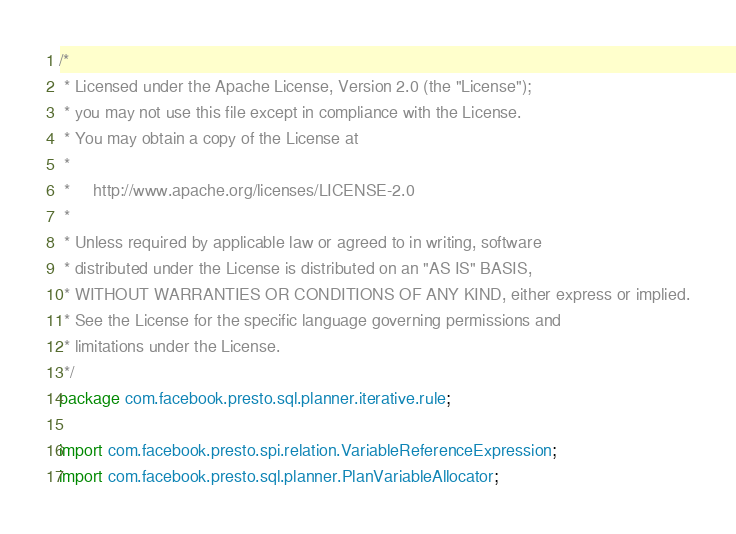Convert code to text. <code><loc_0><loc_0><loc_500><loc_500><_Java_>/*
 * Licensed under the Apache License, Version 2.0 (the "License");
 * you may not use this file except in compliance with the License.
 * You may obtain a copy of the License at
 *
 *     http://www.apache.org/licenses/LICENSE-2.0
 *
 * Unless required by applicable law or agreed to in writing, software
 * distributed under the License is distributed on an "AS IS" BASIS,
 * WITHOUT WARRANTIES OR CONDITIONS OF ANY KIND, either express or implied.
 * See the License for the specific language governing permissions and
 * limitations under the License.
 */
package com.facebook.presto.sql.planner.iterative.rule;

import com.facebook.presto.spi.relation.VariableReferenceExpression;
import com.facebook.presto.sql.planner.PlanVariableAllocator;</code> 